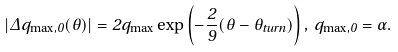<formula> <loc_0><loc_0><loc_500><loc_500>| \Delta q _ { \max , 0 } ( \theta ) | = 2 q _ { \max } \exp \left ( - \frac { 2 } { 9 } ( \theta - \theta _ { t u r n } ) \right ) , \, q _ { \max , 0 } = \alpha .</formula> 